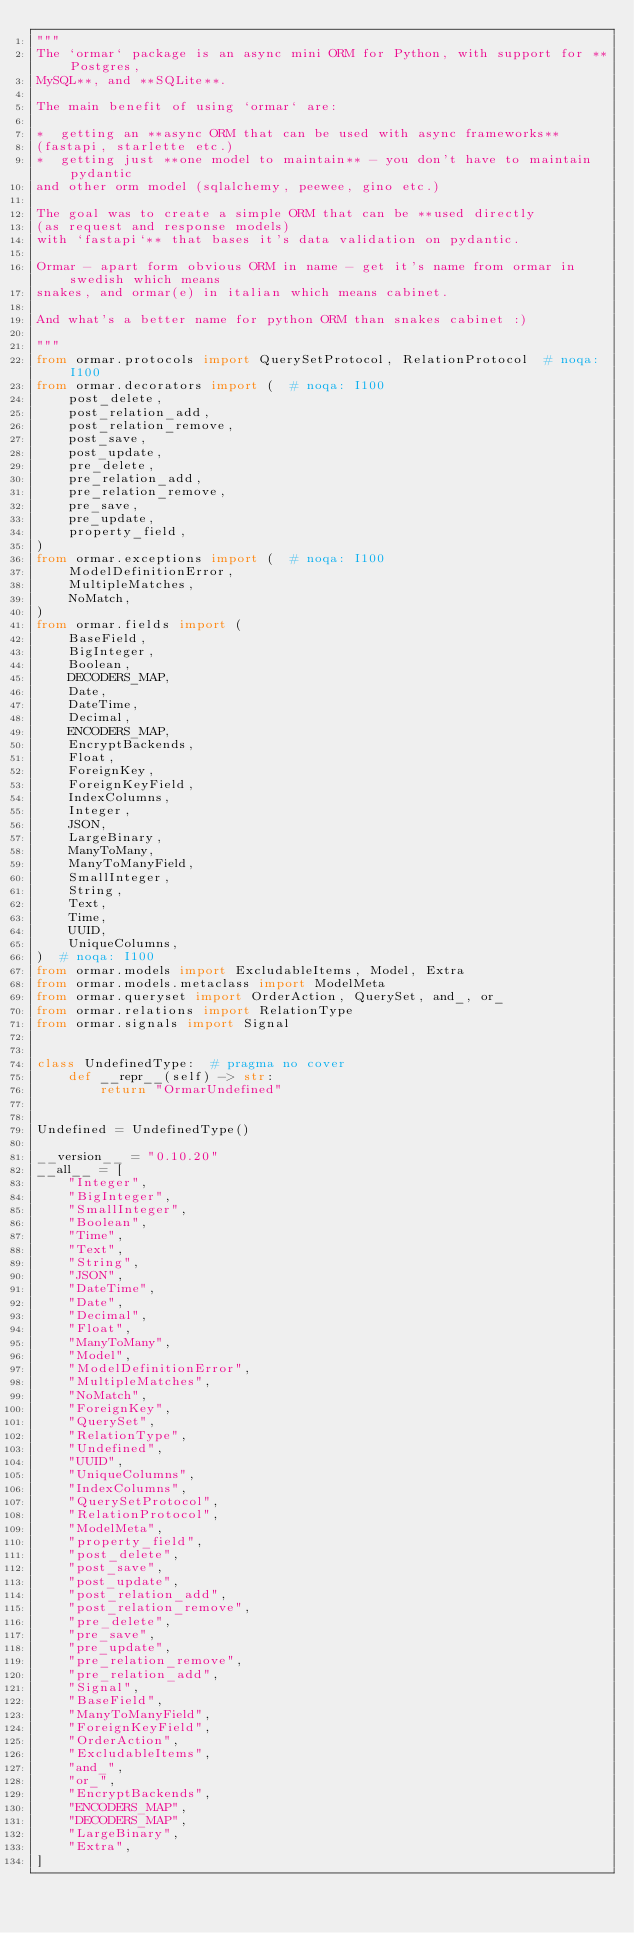Convert code to text. <code><loc_0><loc_0><loc_500><loc_500><_Python_>"""
The `ormar` package is an async mini ORM for Python, with support for **Postgres,
MySQL**, and **SQLite**.

The main benefit of using `ormar` are:

*  getting an **async ORM that can be used with async frameworks**
(fastapi, starlette etc.)
*  getting just **one model to maintain** - you don't have to maintain pydantic
and other orm model (sqlalchemy, peewee, gino etc.)

The goal was to create a simple ORM that can be **used directly
(as request and response models)
with `fastapi`** that bases it's data validation on pydantic.

Ormar - apart form obvious ORM in name - get it's name from ormar in swedish which means
snakes, and ormar(e) in italian which means cabinet.

And what's a better name for python ORM than snakes cabinet :)

"""
from ormar.protocols import QuerySetProtocol, RelationProtocol  # noqa: I100
from ormar.decorators import (  # noqa: I100
    post_delete,
    post_relation_add,
    post_relation_remove,
    post_save,
    post_update,
    pre_delete,
    pre_relation_add,
    pre_relation_remove,
    pre_save,
    pre_update,
    property_field,
)
from ormar.exceptions import (  # noqa: I100
    ModelDefinitionError,
    MultipleMatches,
    NoMatch,
)
from ormar.fields import (
    BaseField,
    BigInteger,
    Boolean,
    DECODERS_MAP,
    Date,
    DateTime,
    Decimal,
    ENCODERS_MAP,
    EncryptBackends,
    Float,
    ForeignKey,
    ForeignKeyField,
    IndexColumns,
    Integer,
    JSON,
    LargeBinary,
    ManyToMany,
    ManyToManyField,
    SmallInteger,
    String,
    Text,
    Time,
    UUID,
    UniqueColumns,
)  # noqa: I100
from ormar.models import ExcludableItems, Model, Extra
from ormar.models.metaclass import ModelMeta
from ormar.queryset import OrderAction, QuerySet, and_, or_
from ormar.relations import RelationType
from ormar.signals import Signal


class UndefinedType:  # pragma no cover
    def __repr__(self) -> str:
        return "OrmarUndefined"


Undefined = UndefinedType()

__version__ = "0.10.20"
__all__ = [
    "Integer",
    "BigInteger",
    "SmallInteger",
    "Boolean",
    "Time",
    "Text",
    "String",
    "JSON",
    "DateTime",
    "Date",
    "Decimal",
    "Float",
    "ManyToMany",
    "Model",
    "ModelDefinitionError",
    "MultipleMatches",
    "NoMatch",
    "ForeignKey",
    "QuerySet",
    "RelationType",
    "Undefined",
    "UUID",
    "UniqueColumns",
    "IndexColumns",
    "QuerySetProtocol",
    "RelationProtocol",
    "ModelMeta",
    "property_field",
    "post_delete",
    "post_save",
    "post_update",
    "post_relation_add",
    "post_relation_remove",
    "pre_delete",
    "pre_save",
    "pre_update",
    "pre_relation_remove",
    "pre_relation_add",
    "Signal",
    "BaseField",
    "ManyToManyField",
    "ForeignKeyField",
    "OrderAction",
    "ExcludableItems",
    "and_",
    "or_",
    "EncryptBackends",
    "ENCODERS_MAP",
    "DECODERS_MAP",
    "LargeBinary",
    "Extra",
]
</code> 